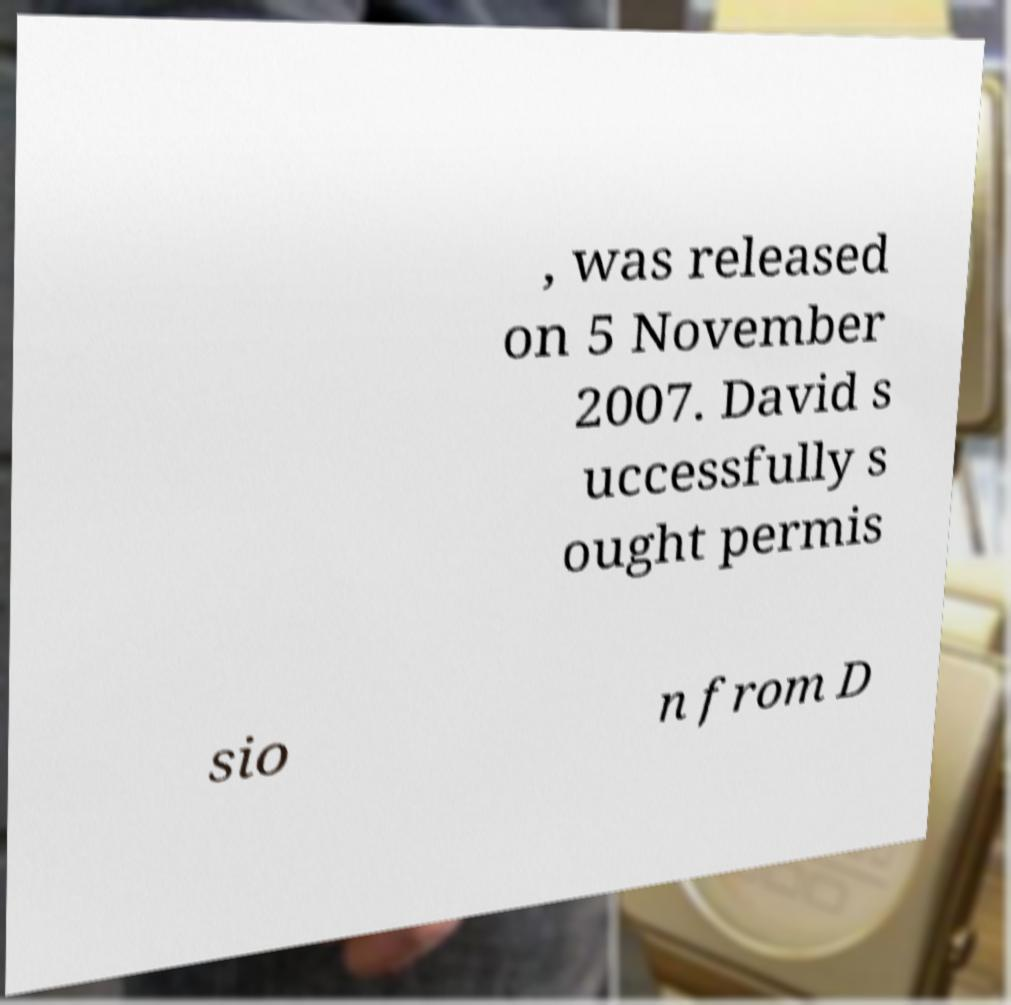Could you extract and type out the text from this image? , was released on 5 November 2007. David s uccessfully s ought permis sio n from D 